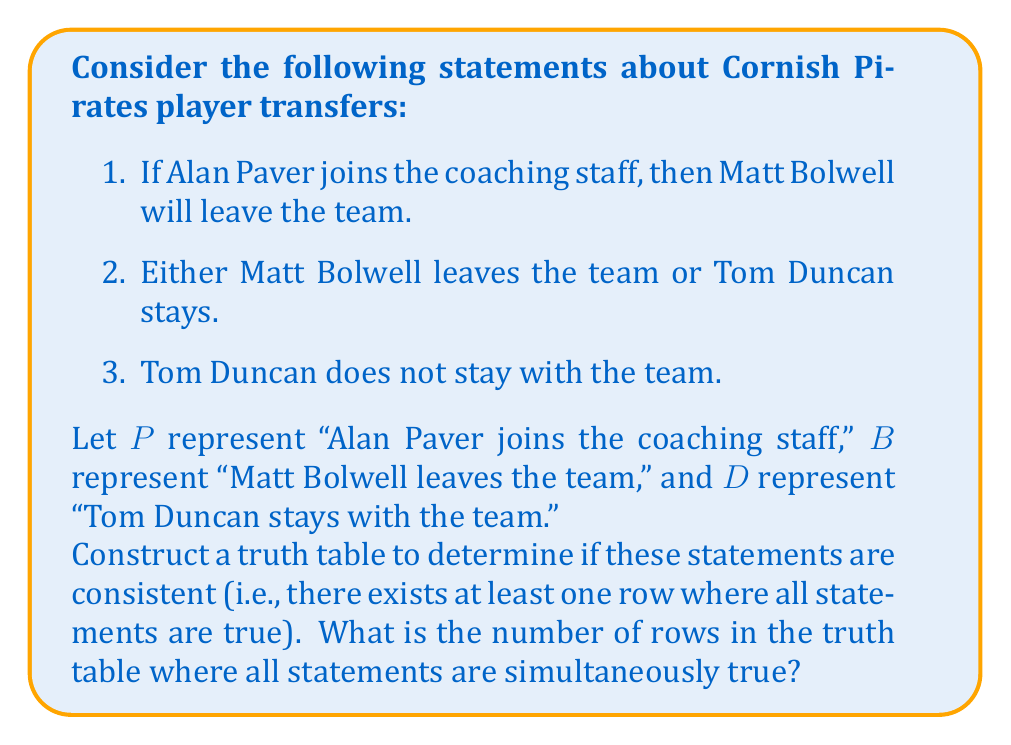Show me your answer to this math problem. To analyze the consistency of these statements, we need to construct a truth table and evaluate each statement for all possible combinations of truth values for P, B, and D.

Let's translate the statements into logical expressions:
1. $P \rightarrow B$
2. $B \lor D$
3. $\lnot D$

Now, let's construct the truth table:

$$
\begin{array}{|c|c|c||c|c|c||c|}
\hline
P & B & D & P \rightarrow B & B \lor D & \lnot D & \text{All True?} \\
\hline
T & T & T & T & T & F & F \\
T & T & F & T & T & T & T \\
T & F & T & F & T & F & F \\
T & F & F & F & F & T & F \\
F & T & T & T & T & F & F \\
F & T & F & T & T & T & T \\
F & F & T & T & T & F & F \\
F & F & F & T & F & T & F \\
\hline
\end{array}
$$

To determine if the statements are consistent, we need to check if there is at least one row where all statements are true. Looking at the rightmost column, we can see that there are two rows where all statements are simultaneously true.

These rows correspond to the following scenarios:
1. Alan Paver joins the coaching staff (P is true), Matt Bolwell leaves the team (B is true), and Tom Duncan does not stay (D is false).
2. Alan Paver does not join the coaching staff (P is false), Matt Bolwell leaves the team (B is true), and Tom Duncan does not stay (D is false).

Since there exists at least one row where all statements are true, we can conclude that these statements are consistent.
Answer: The number of rows in the truth table where all statements are simultaneously true is 2. 